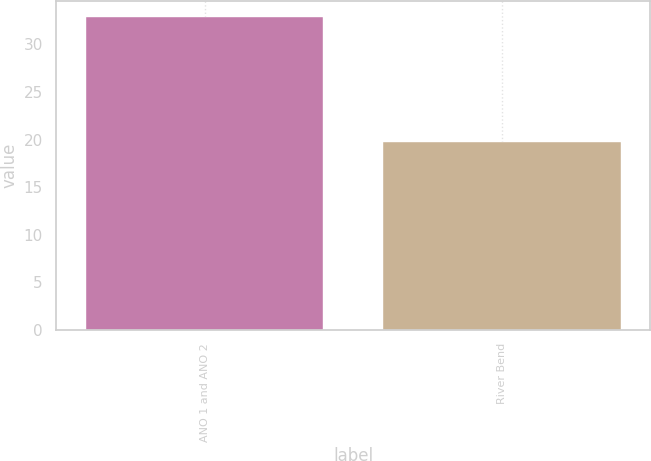Convert chart to OTSL. <chart><loc_0><loc_0><loc_500><loc_500><bar_chart><fcel>ANO 1 and ANO 2<fcel>River Bend<nl><fcel>32.9<fcel>19.7<nl></chart> 